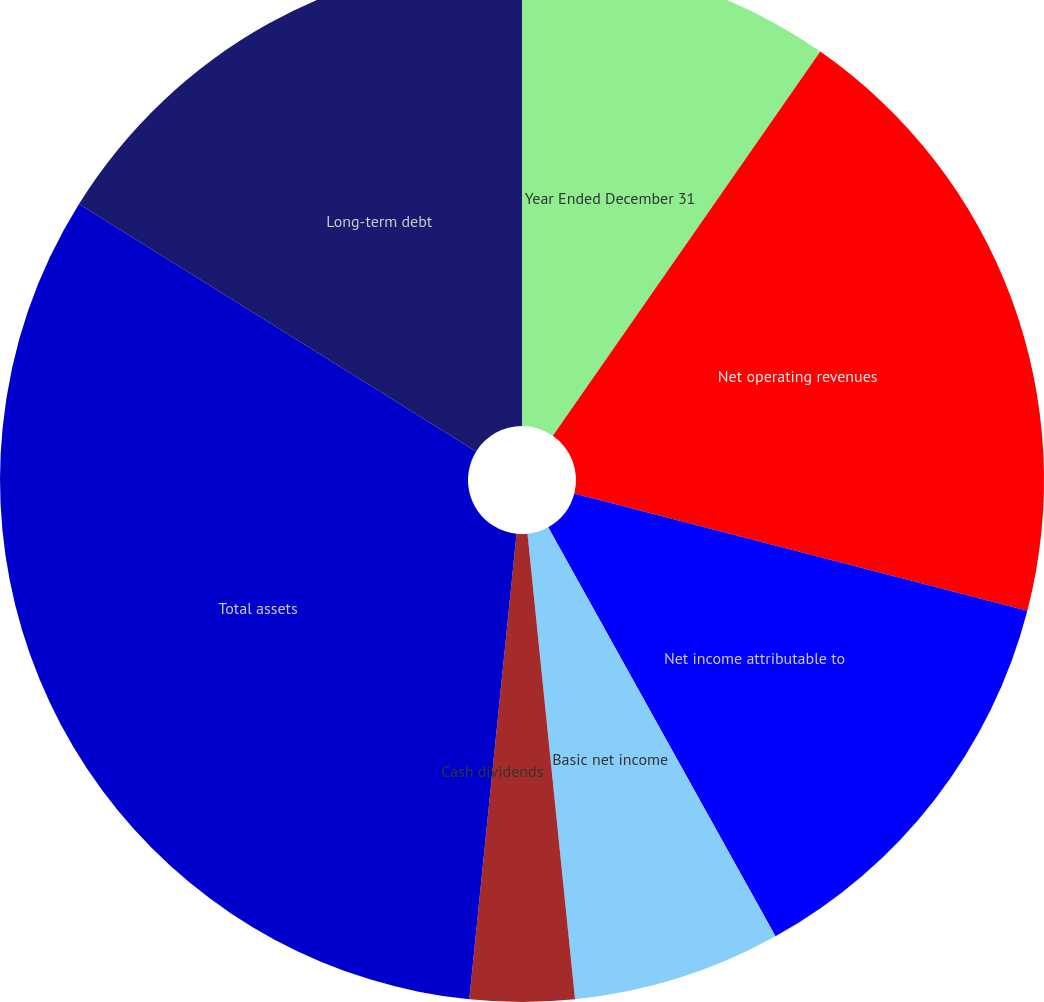Convert chart. <chart><loc_0><loc_0><loc_500><loc_500><pie_chart><fcel>Year Ended December 31<fcel>Net operating revenues<fcel>Net income attributable to<fcel>Basic net income<fcel>Diluted net income<fcel>Cash dividends<fcel>Total assets<fcel>Long-term debt<nl><fcel>9.68%<fcel>19.35%<fcel>12.9%<fcel>6.45%<fcel>3.23%<fcel>0.0%<fcel>32.26%<fcel>16.13%<nl></chart> 